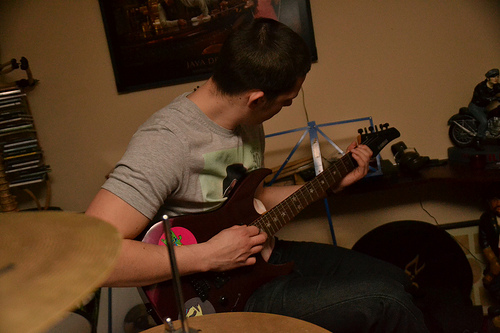<image>
Can you confirm if the cds is behind the guitar? Yes. From this viewpoint, the cds is positioned behind the guitar, with the guitar partially or fully occluding the cds. Where is the cymbal in relation to the man? Is it behind the man? No. The cymbal is not behind the man. From this viewpoint, the cymbal appears to be positioned elsewhere in the scene. 